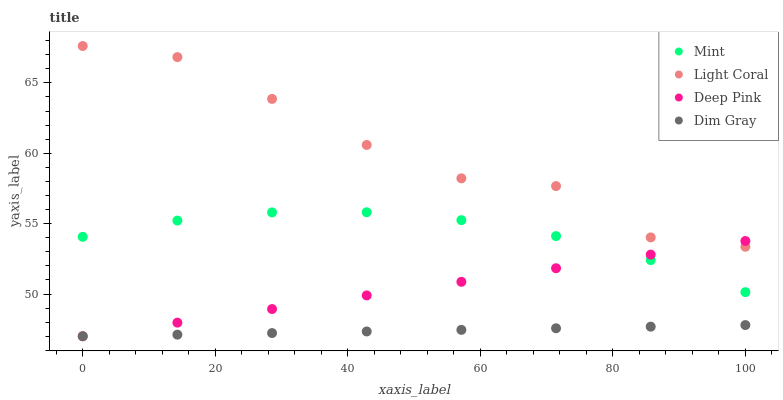Does Dim Gray have the minimum area under the curve?
Answer yes or no. Yes. Does Light Coral have the maximum area under the curve?
Answer yes or no. Yes. Does Deep Pink have the minimum area under the curve?
Answer yes or no. No. Does Deep Pink have the maximum area under the curve?
Answer yes or no. No. Is Dim Gray the smoothest?
Answer yes or no. Yes. Is Light Coral the roughest?
Answer yes or no. Yes. Is Deep Pink the smoothest?
Answer yes or no. No. Is Deep Pink the roughest?
Answer yes or no. No. Does Dim Gray have the lowest value?
Answer yes or no. Yes. Does Mint have the lowest value?
Answer yes or no. No. Does Light Coral have the highest value?
Answer yes or no. Yes. Does Deep Pink have the highest value?
Answer yes or no. No. Is Dim Gray less than Mint?
Answer yes or no. Yes. Is Light Coral greater than Dim Gray?
Answer yes or no. Yes. Does Deep Pink intersect Light Coral?
Answer yes or no. Yes. Is Deep Pink less than Light Coral?
Answer yes or no. No. Is Deep Pink greater than Light Coral?
Answer yes or no. No. Does Dim Gray intersect Mint?
Answer yes or no. No. 